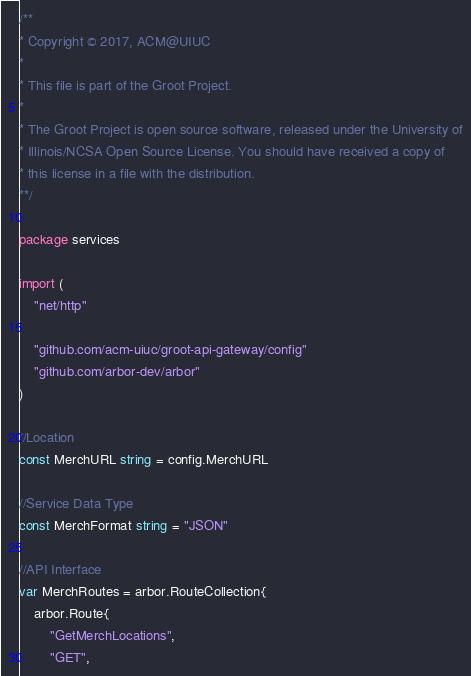Convert code to text. <code><loc_0><loc_0><loc_500><loc_500><_Go_>/**
* Copyright © 2017, ACM@UIUC
*
* This file is part of the Groot Project.
*
* The Groot Project is open source software, released under the University of
* Illinois/NCSA Open Source License. You should have received a copy of
* this license in a file with the distribution.
**/

package services

import (
	"net/http"

	"github.com/acm-uiuc/groot-api-gateway/config"
	"github.com/arbor-dev/arbor"
)

//Location
const MerchURL string = config.MerchURL

//Service Data Type
const MerchFormat string = "JSON"

//API Interface
var MerchRoutes = arbor.RouteCollection{
	arbor.Route{
		"GetMerchLocations",
		"GET",</code> 